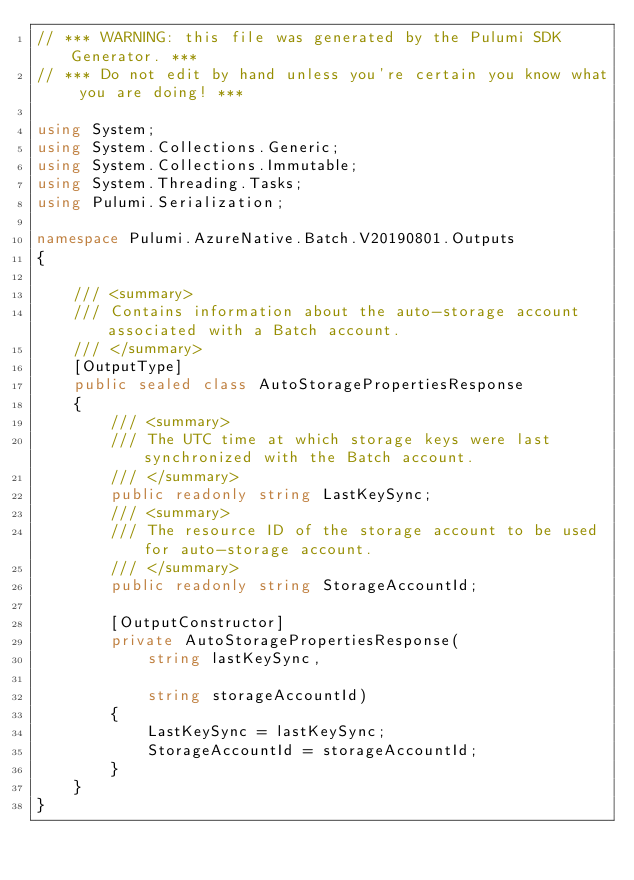<code> <loc_0><loc_0><loc_500><loc_500><_C#_>// *** WARNING: this file was generated by the Pulumi SDK Generator. ***
// *** Do not edit by hand unless you're certain you know what you are doing! ***

using System;
using System.Collections.Generic;
using System.Collections.Immutable;
using System.Threading.Tasks;
using Pulumi.Serialization;

namespace Pulumi.AzureNative.Batch.V20190801.Outputs
{

    /// <summary>
    /// Contains information about the auto-storage account associated with a Batch account.
    /// </summary>
    [OutputType]
    public sealed class AutoStoragePropertiesResponse
    {
        /// <summary>
        /// The UTC time at which storage keys were last synchronized with the Batch account.
        /// </summary>
        public readonly string LastKeySync;
        /// <summary>
        /// The resource ID of the storage account to be used for auto-storage account.
        /// </summary>
        public readonly string StorageAccountId;

        [OutputConstructor]
        private AutoStoragePropertiesResponse(
            string lastKeySync,

            string storageAccountId)
        {
            LastKeySync = lastKeySync;
            StorageAccountId = storageAccountId;
        }
    }
}
</code> 